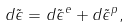<formula> <loc_0><loc_0><loc_500><loc_500>d \tilde { \epsilon } = d \tilde { \epsilon } ^ { e } + d \tilde { \epsilon } ^ { p } ,</formula> 